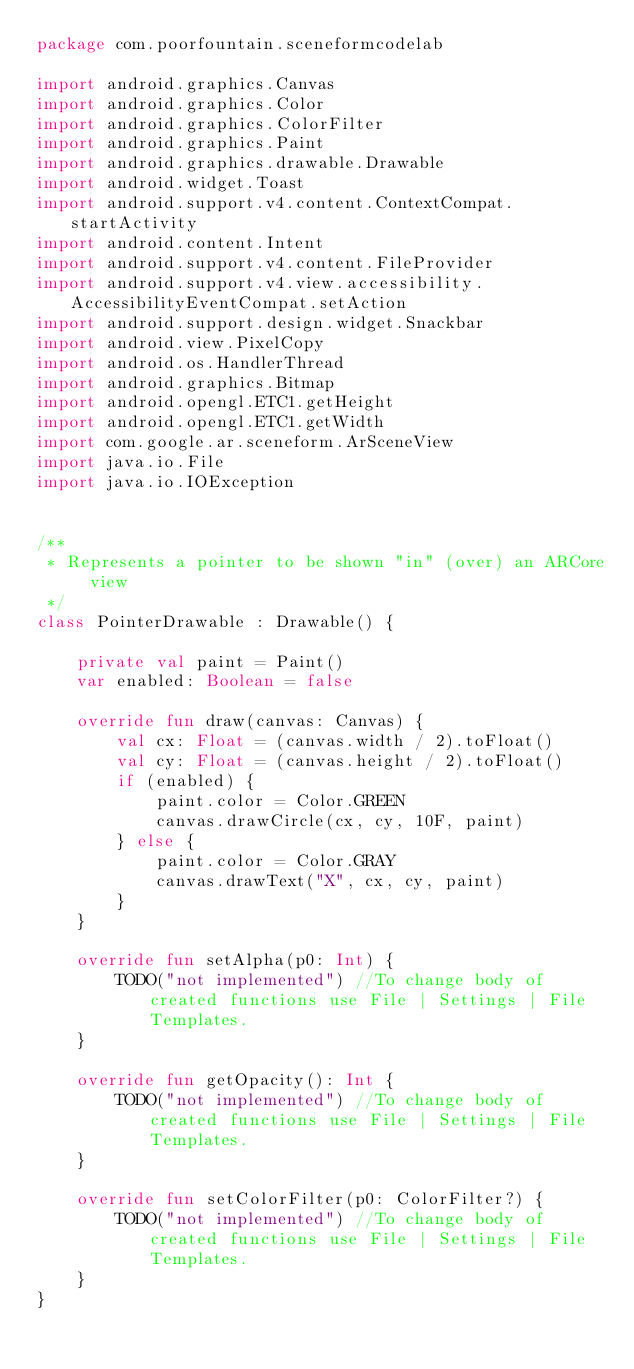Convert code to text. <code><loc_0><loc_0><loc_500><loc_500><_Kotlin_>package com.poorfountain.sceneformcodelab

import android.graphics.Canvas
import android.graphics.Color
import android.graphics.ColorFilter
import android.graphics.Paint
import android.graphics.drawable.Drawable
import android.widget.Toast
import android.support.v4.content.ContextCompat.startActivity
import android.content.Intent
import android.support.v4.content.FileProvider
import android.support.v4.view.accessibility.AccessibilityEventCompat.setAction
import android.support.design.widget.Snackbar
import android.view.PixelCopy
import android.os.HandlerThread
import android.graphics.Bitmap
import android.opengl.ETC1.getHeight
import android.opengl.ETC1.getWidth
import com.google.ar.sceneform.ArSceneView
import java.io.File
import java.io.IOException


/**
 * Represents a pointer to be shown "in" (over) an ARCore view
 */
class PointerDrawable : Drawable() {

    private val paint = Paint()
    var enabled: Boolean = false

    override fun draw(canvas: Canvas) {
        val cx: Float = (canvas.width / 2).toFloat()
        val cy: Float = (canvas.height / 2).toFloat()
        if (enabled) {
            paint.color = Color.GREEN
            canvas.drawCircle(cx, cy, 10F, paint)
        } else {
            paint.color = Color.GRAY
            canvas.drawText("X", cx, cy, paint)
        }
    }

    override fun setAlpha(p0: Int) {
        TODO("not implemented") //To change body of created functions use File | Settings | File Templates.
    }

    override fun getOpacity(): Int {
        TODO("not implemented") //To change body of created functions use File | Settings | File Templates.
    }

    override fun setColorFilter(p0: ColorFilter?) {
        TODO("not implemented") //To change body of created functions use File | Settings | File Templates.
    }
}</code> 